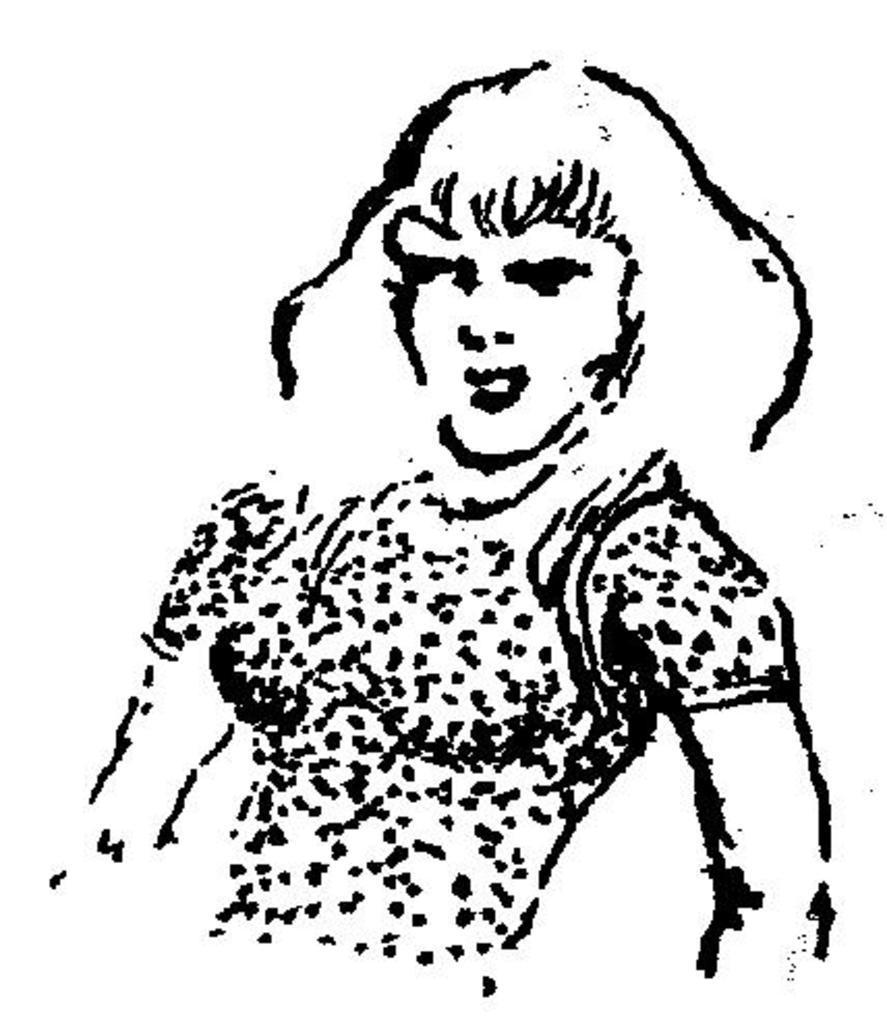Could you give a brief overview of what you see in this image? In this image we can see the drawing of a person. In the background the image is white in color. 